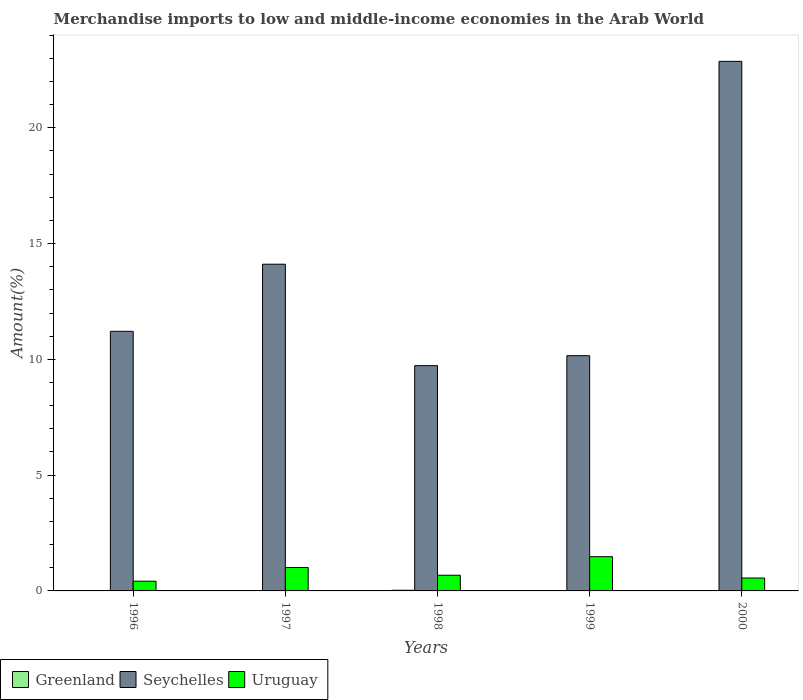How many different coloured bars are there?
Provide a succinct answer. 3. Are the number of bars on each tick of the X-axis equal?
Make the answer very short. Yes. How many bars are there on the 2nd tick from the right?
Make the answer very short. 3. What is the label of the 2nd group of bars from the left?
Your answer should be compact. 1997. In how many cases, is the number of bars for a given year not equal to the number of legend labels?
Your response must be concise. 0. What is the percentage of amount earned from merchandise imports in Seychelles in 1999?
Your response must be concise. 10.16. Across all years, what is the maximum percentage of amount earned from merchandise imports in Greenland?
Provide a succinct answer. 0.03. Across all years, what is the minimum percentage of amount earned from merchandise imports in Greenland?
Provide a succinct answer. 0. What is the total percentage of amount earned from merchandise imports in Uruguay in the graph?
Your response must be concise. 4.14. What is the difference between the percentage of amount earned from merchandise imports in Seychelles in 1996 and that in 1998?
Your answer should be very brief. 1.48. What is the difference between the percentage of amount earned from merchandise imports in Uruguay in 1997 and the percentage of amount earned from merchandise imports in Seychelles in 1999?
Your response must be concise. -9.15. What is the average percentage of amount earned from merchandise imports in Greenland per year?
Your response must be concise. 0.01. In the year 1998, what is the difference between the percentage of amount earned from merchandise imports in Greenland and percentage of amount earned from merchandise imports in Uruguay?
Keep it short and to the point. -0.65. In how many years, is the percentage of amount earned from merchandise imports in Uruguay greater than 6 %?
Ensure brevity in your answer.  0. What is the ratio of the percentage of amount earned from merchandise imports in Greenland in 1996 to that in 1997?
Offer a very short reply. 0.96. Is the difference between the percentage of amount earned from merchandise imports in Greenland in 1998 and 1999 greater than the difference between the percentage of amount earned from merchandise imports in Uruguay in 1998 and 1999?
Offer a terse response. Yes. What is the difference between the highest and the second highest percentage of amount earned from merchandise imports in Uruguay?
Ensure brevity in your answer.  0.47. What is the difference between the highest and the lowest percentage of amount earned from merchandise imports in Greenland?
Provide a short and direct response. 0.03. In how many years, is the percentage of amount earned from merchandise imports in Seychelles greater than the average percentage of amount earned from merchandise imports in Seychelles taken over all years?
Provide a short and direct response. 2. Is the sum of the percentage of amount earned from merchandise imports in Greenland in 1996 and 1998 greater than the maximum percentage of amount earned from merchandise imports in Seychelles across all years?
Offer a very short reply. No. What does the 2nd bar from the left in 1999 represents?
Your answer should be very brief. Seychelles. What does the 2nd bar from the right in 1996 represents?
Offer a terse response. Seychelles. Is it the case that in every year, the sum of the percentage of amount earned from merchandise imports in Uruguay and percentage of amount earned from merchandise imports in Seychelles is greater than the percentage of amount earned from merchandise imports in Greenland?
Your answer should be very brief. Yes. How many bars are there?
Give a very brief answer. 15. Are all the bars in the graph horizontal?
Your answer should be compact. No. How many years are there in the graph?
Provide a short and direct response. 5. Are the values on the major ticks of Y-axis written in scientific E-notation?
Provide a short and direct response. No. How many legend labels are there?
Give a very brief answer. 3. How are the legend labels stacked?
Provide a succinct answer. Horizontal. What is the title of the graph?
Give a very brief answer. Merchandise imports to low and middle-income economies in the Arab World. What is the label or title of the Y-axis?
Your answer should be compact. Amount(%). What is the Amount(%) in Greenland in 1996?
Your response must be concise. 0.01. What is the Amount(%) in Seychelles in 1996?
Keep it short and to the point. 11.21. What is the Amount(%) of Uruguay in 1996?
Provide a succinct answer. 0.42. What is the Amount(%) in Greenland in 1997?
Offer a terse response. 0.01. What is the Amount(%) in Seychelles in 1997?
Make the answer very short. 14.11. What is the Amount(%) of Uruguay in 1997?
Ensure brevity in your answer.  1.01. What is the Amount(%) in Greenland in 1998?
Offer a very short reply. 0.03. What is the Amount(%) in Seychelles in 1998?
Make the answer very short. 9.73. What is the Amount(%) in Uruguay in 1998?
Your answer should be compact. 0.68. What is the Amount(%) of Greenland in 1999?
Give a very brief answer. 0.01. What is the Amount(%) of Seychelles in 1999?
Provide a succinct answer. 10.16. What is the Amount(%) in Uruguay in 1999?
Provide a short and direct response. 1.48. What is the Amount(%) in Greenland in 2000?
Offer a terse response. 0. What is the Amount(%) of Seychelles in 2000?
Ensure brevity in your answer.  22.87. What is the Amount(%) of Uruguay in 2000?
Offer a terse response. 0.56. Across all years, what is the maximum Amount(%) of Greenland?
Ensure brevity in your answer.  0.03. Across all years, what is the maximum Amount(%) of Seychelles?
Make the answer very short. 22.87. Across all years, what is the maximum Amount(%) of Uruguay?
Provide a short and direct response. 1.48. Across all years, what is the minimum Amount(%) of Greenland?
Make the answer very short. 0. Across all years, what is the minimum Amount(%) in Seychelles?
Offer a very short reply. 9.73. Across all years, what is the minimum Amount(%) of Uruguay?
Your answer should be very brief. 0.42. What is the total Amount(%) of Greenland in the graph?
Offer a very short reply. 0.06. What is the total Amount(%) in Seychelles in the graph?
Ensure brevity in your answer.  68.08. What is the total Amount(%) in Uruguay in the graph?
Provide a short and direct response. 4.14. What is the difference between the Amount(%) of Greenland in 1996 and that in 1997?
Make the answer very short. -0. What is the difference between the Amount(%) of Seychelles in 1996 and that in 1997?
Offer a very short reply. -2.9. What is the difference between the Amount(%) of Uruguay in 1996 and that in 1997?
Provide a succinct answer. -0.59. What is the difference between the Amount(%) of Greenland in 1996 and that in 1998?
Provide a short and direct response. -0.02. What is the difference between the Amount(%) in Seychelles in 1996 and that in 1998?
Offer a very short reply. 1.48. What is the difference between the Amount(%) in Uruguay in 1996 and that in 1998?
Offer a terse response. -0.26. What is the difference between the Amount(%) of Greenland in 1996 and that in 1999?
Your answer should be compact. 0.01. What is the difference between the Amount(%) of Seychelles in 1996 and that in 1999?
Ensure brevity in your answer.  1.05. What is the difference between the Amount(%) of Uruguay in 1996 and that in 1999?
Provide a short and direct response. -1.06. What is the difference between the Amount(%) in Greenland in 1996 and that in 2000?
Ensure brevity in your answer.  0.01. What is the difference between the Amount(%) of Seychelles in 1996 and that in 2000?
Offer a very short reply. -11.66. What is the difference between the Amount(%) of Uruguay in 1996 and that in 2000?
Offer a very short reply. -0.14. What is the difference between the Amount(%) in Greenland in 1997 and that in 1998?
Make the answer very short. -0.02. What is the difference between the Amount(%) of Seychelles in 1997 and that in 1998?
Give a very brief answer. 4.38. What is the difference between the Amount(%) in Uruguay in 1997 and that in 1998?
Offer a very short reply. 0.33. What is the difference between the Amount(%) of Greenland in 1997 and that in 1999?
Keep it short and to the point. 0.01. What is the difference between the Amount(%) of Seychelles in 1997 and that in 1999?
Provide a succinct answer. 3.95. What is the difference between the Amount(%) in Uruguay in 1997 and that in 1999?
Give a very brief answer. -0.47. What is the difference between the Amount(%) in Greenland in 1997 and that in 2000?
Make the answer very short. 0.01. What is the difference between the Amount(%) of Seychelles in 1997 and that in 2000?
Give a very brief answer. -8.76. What is the difference between the Amount(%) in Uruguay in 1997 and that in 2000?
Provide a succinct answer. 0.46. What is the difference between the Amount(%) in Greenland in 1998 and that in 1999?
Provide a short and direct response. 0.02. What is the difference between the Amount(%) in Seychelles in 1998 and that in 1999?
Your response must be concise. -0.43. What is the difference between the Amount(%) in Uruguay in 1998 and that in 1999?
Keep it short and to the point. -0.8. What is the difference between the Amount(%) of Greenland in 1998 and that in 2000?
Your answer should be very brief. 0.03. What is the difference between the Amount(%) of Seychelles in 1998 and that in 2000?
Provide a succinct answer. -13.14. What is the difference between the Amount(%) in Uruguay in 1998 and that in 2000?
Your answer should be very brief. 0.12. What is the difference between the Amount(%) of Greenland in 1999 and that in 2000?
Offer a terse response. 0.01. What is the difference between the Amount(%) in Seychelles in 1999 and that in 2000?
Keep it short and to the point. -12.71. What is the difference between the Amount(%) in Uruguay in 1999 and that in 2000?
Your answer should be very brief. 0.92. What is the difference between the Amount(%) in Greenland in 1996 and the Amount(%) in Seychelles in 1997?
Give a very brief answer. -14.1. What is the difference between the Amount(%) in Greenland in 1996 and the Amount(%) in Uruguay in 1997?
Give a very brief answer. -1. What is the difference between the Amount(%) in Seychelles in 1996 and the Amount(%) in Uruguay in 1997?
Provide a short and direct response. 10.2. What is the difference between the Amount(%) of Greenland in 1996 and the Amount(%) of Seychelles in 1998?
Keep it short and to the point. -9.72. What is the difference between the Amount(%) of Greenland in 1996 and the Amount(%) of Uruguay in 1998?
Provide a succinct answer. -0.67. What is the difference between the Amount(%) in Seychelles in 1996 and the Amount(%) in Uruguay in 1998?
Ensure brevity in your answer.  10.53. What is the difference between the Amount(%) of Greenland in 1996 and the Amount(%) of Seychelles in 1999?
Your response must be concise. -10.15. What is the difference between the Amount(%) of Greenland in 1996 and the Amount(%) of Uruguay in 1999?
Your answer should be compact. -1.47. What is the difference between the Amount(%) of Seychelles in 1996 and the Amount(%) of Uruguay in 1999?
Your answer should be very brief. 9.73. What is the difference between the Amount(%) of Greenland in 1996 and the Amount(%) of Seychelles in 2000?
Ensure brevity in your answer.  -22.86. What is the difference between the Amount(%) in Greenland in 1996 and the Amount(%) in Uruguay in 2000?
Keep it short and to the point. -0.54. What is the difference between the Amount(%) of Seychelles in 1996 and the Amount(%) of Uruguay in 2000?
Your response must be concise. 10.65. What is the difference between the Amount(%) in Greenland in 1997 and the Amount(%) in Seychelles in 1998?
Keep it short and to the point. -9.72. What is the difference between the Amount(%) of Greenland in 1997 and the Amount(%) of Uruguay in 1998?
Provide a succinct answer. -0.66. What is the difference between the Amount(%) of Seychelles in 1997 and the Amount(%) of Uruguay in 1998?
Your answer should be compact. 13.43. What is the difference between the Amount(%) of Greenland in 1997 and the Amount(%) of Seychelles in 1999?
Provide a short and direct response. -10.15. What is the difference between the Amount(%) in Greenland in 1997 and the Amount(%) in Uruguay in 1999?
Give a very brief answer. -1.47. What is the difference between the Amount(%) of Seychelles in 1997 and the Amount(%) of Uruguay in 1999?
Provide a succinct answer. 12.63. What is the difference between the Amount(%) of Greenland in 1997 and the Amount(%) of Seychelles in 2000?
Your answer should be very brief. -22.86. What is the difference between the Amount(%) in Greenland in 1997 and the Amount(%) in Uruguay in 2000?
Your response must be concise. -0.54. What is the difference between the Amount(%) of Seychelles in 1997 and the Amount(%) of Uruguay in 2000?
Ensure brevity in your answer.  13.55. What is the difference between the Amount(%) in Greenland in 1998 and the Amount(%) in Seychelles in 1999?
Offer a very short reply. -10.13. What is the difference between the Amount(%) in Greenland in 1998 and the Amount(%) in Uruguay in 1999?
Keep it short and to the point. -1.45. What is the difference between the Amount(%) in Seychelles in 1998 and the Amount(%) in Uruguay in 1999?
Make the answer very short. 8.25. What is the difference between the Amount(%) in Greenland in 1998 and the Amount(%) in Seychelles in 2000?
Provide a short and direct response. -22.84. What is the difference between the Amount(%) of Greenland in 1998 and the Amount(%) of Uruguay in 2000?
Provide a succinct answer. -0.53. What is the difference between the Amount(%) in Seychelles in 1998 and the Amount(%) in Uruguay in 2000?
Your response must be concise. 9.17. What is the difference between the Amount(%) of Greenland in 1999 and the Amount(%) of Seychelles in 2000?
Give a very brief answer. -22.86. What is the difference between the Amount(%) in Greenland in 1999 and the Amount(%) in Uruguay in 2000?
Your response must be concise. -0.55. What is the difference between the Amount(%) in Seychelles in 1999 and the Amount(%) in Uruguay in 2000?
Give a very brief answer. 9.6. What is the average Amount(%) of Greenland per year?
Offer a terse response. 0.01. What is the average Amount(%) in Seychelles per year?
Offer a very short reply. 13.62. What is the average Amount(%) of Uruguay per year?
Your response must be concise. 0.83. In the year 1996, what is the difference between the Amount(%) in Greenland and Amount(%) in Seychelles?
Give a very brief answer. -11.2. In the year 1996, what is the difference between the Amount(%) in Greenland and Amount(%) in Uruguay?
Your answer should be compact. -0.41. In the year 1996, what is the difference between the Amount(%) in Seychelles and Amount(%) in Uruguay?
Ensure brevity in your answer.  10.79. In the year 1997, what is the difference between the Amount(%) in Greenland and Amount(%) in Seychelles?
Offer a terse response. -14.1. In the year 1997, what is the difference between the Amount(%) in Greenland and Amount(%) in Uruguay?
Your answer should be compact. -1. In the year 1997, what is the difference between the Amount(%) in Seychelles and Amount(%) in Uruguay?
Offer a terse response. 13.1. In the year 1998, what is the difference between the Amount(%) in Greenland and Amount(%) in Seychelles?
Keep it short and to the point. -9.7. In the year 1998, what is the difference between the Amount(%) in Greenland and Amount(%) in Uruguay?
Offer a very short reply. -0.65. In the year 1998, what is the difference between the Amount(%) of Seychelles and Amount(%) of Uruguay?
Keep it short and to the point. 9.05. In the year 1999, what is the difference between the Amount(%) in Greenland and Amount(%) in Seychelles?
Keep it short and to the point. -10.15. In the year 1999, what is the difference between the Amount(%) in Greenland and Amount(%) in Uruguay?
Offer a terse response. -1.47. In the year 1999, what is the difference between the Amount(%) in Seychelles and Amount(%) in Uruguay?
Offer a very short reply. 8.68. In the year 2000, what is the difference between the Amount(%) of Greenland and Amount(%) of Seychelles?
Offer a very short reply. -22.87. In the year 2000, what is the difference between the Amount(%) of Greenland and Amount(%) of Uruguay?
Your answer should be compact. -0.56. In the year 2000, what is the difference between the Amount(%) of Seychelles and Amount(%) of Uruguay?
Offer a very short reply. 22.31. What is the ratio of the Amount(%) in Greenland in 1996 to that in 1997?
Offer a very short reply. 0.96. What is the ratio of the Amount(%) in Seychelles in 1996 to that in 1997?
Give a very brief answer. 0.79. What is the ratio of the Amount(%) of Uruguay in 1996 to that in 1997?
Make the answer very short. 0.42. What is the ratio of the Amount(%) in Greenland in 1996 to that in 1998?
Keep it short and to the point. 0.43. What is the ratio of the Amount(%) in Seychelles in 1996 to that in 1998?
Your response must be concise. 1.15. What is the ratio of the Amount(%) in Uruguay in 1996 to that in 1998?
Keep it short and to the point. 0.62. What is the ratio of the Amount(%) of Greenland in 1996 to that in 1999?
Give a very brief answer. 1.85. What is the ratio of the Amount(%) of Seychelles in 1996 to that in 1999?
Offer a terse response. 1.1. What is the ratio of the Amount(%) in Uruguay in 1996 to that in 1999?
Provide a succinct answer. 0.28. What is the ratio of the Amount(%) in Greenland in 1996 to that in 2000?
Offer a very short reply. 12.02. What is the ratio of the Amount(%) of Seychelles in 1996 to that in 2000?
Give a very brief answer. 0.49. What is the ratio of the Amount(%) in Uruguay in 1996 to that in 2000?
Your answer should be compact. 0.75. What is the ratio of the Amount(%) of Greenland in 1997 to that in 1998?
Ensure brevity in your answer.  0.44. What is the ratio of the Amount(%) of Seychelles in 1997 to that in 1998?
Offer a very short reply. 1.45. What is the ratio of the Amount(%) in Uruguay in 1997 to that in 1998?
Your response must be concise. 1.49. What is the ratio of the Amount(%) in Greenland in 1997 to that in 1999?
Provide a succinct answer. 1.92. What is the ratio of the Amount(%) in Seychelles in 1997 to that in 1999?
Your answer should be very brief. 1.39. What is the ratio of the Amount(%) of Uruguay in 1997 to that in 1999?
Make the answer very short. 0.68. What is the ratio of the Amount(%) in Greenland in 1997 to that in 2000?
Provide a short and direct response. 12.47. What is the ratio of the Amount(%) of Seychelles in 1997 to that in 2000?
Provide a succinct answer. 0.62. What is the ratio of the Amount(%) of Uruguay in 1997 to that in 2000?
Your answer should be very brief. 1.82. What is the ratio of the Amount(%) of Greenland in 1998 to that in 1999?
Your response must be concise. 4.35. What is the ratio of the Amount(%) in Seychelles in 1998 to that in 1999?
Provide a short and direct response. 0.96. What is the ratio of the Amount(%) of Uruguay in 1998 to that in 1999?
Make the answer very short. 0.46. What is the ratio of the Amount(%) in Greenland in 1998 to that in 2000?
Offer a terse response. 28.18. What is the ratio of the Amount(%) of Seychelles in 1998 to that in 2000?
Make the answer very short. 0.43. What is the ratio of the Amount(%) of Uruguay in 1998 to that in 2000?
Make the answer very short. 1.22. What is the ratio of the Amount(%) of Greenland in 1999 to that in 2000?
Your answer should be very brief. 6.48. What is the ratio of the Amount(%) in Seychelles in 1999 to that in 2000?
Your answer should be compact. 0.44. What is the ratio of the Amount(%) in Uruguay in 1999 to that in 2000?
Ensure brevity in your answer.  2.65. What is the difference between the highest and the second highest Amount(%) in Greenland?
Make the answer very short. 0.02. What is the difference between the highest and the second highest Amount(%) in Seychelles?
Give a very brief answer. 8.76. What is the difference between the highest and the second highest Amount(%) of Uruguay?
Give a very brief answer. 0.47. What is the difference between the highest and the lowest Amount(%) in Greenland?
Provide a short and direct response. 0.03. What is the difference between the highest and the lowest Amount(%) of Seychelles?
Your answer should be very brief. 13.14. What is the difference between the highest and the lowest Amount(%) in Uruguay?
Offer a very short reply. 1.06. 